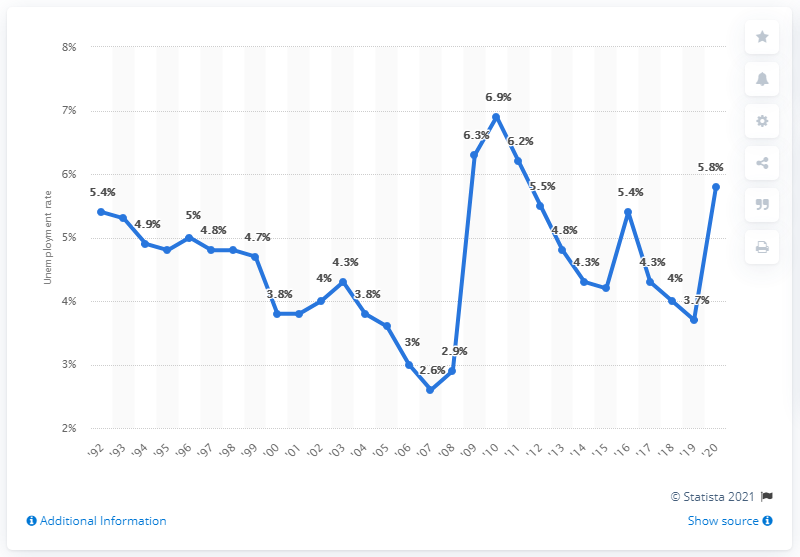Identify some key points in this picture. In 2020, the unemployment rate in Wyoming was 5.8%. 